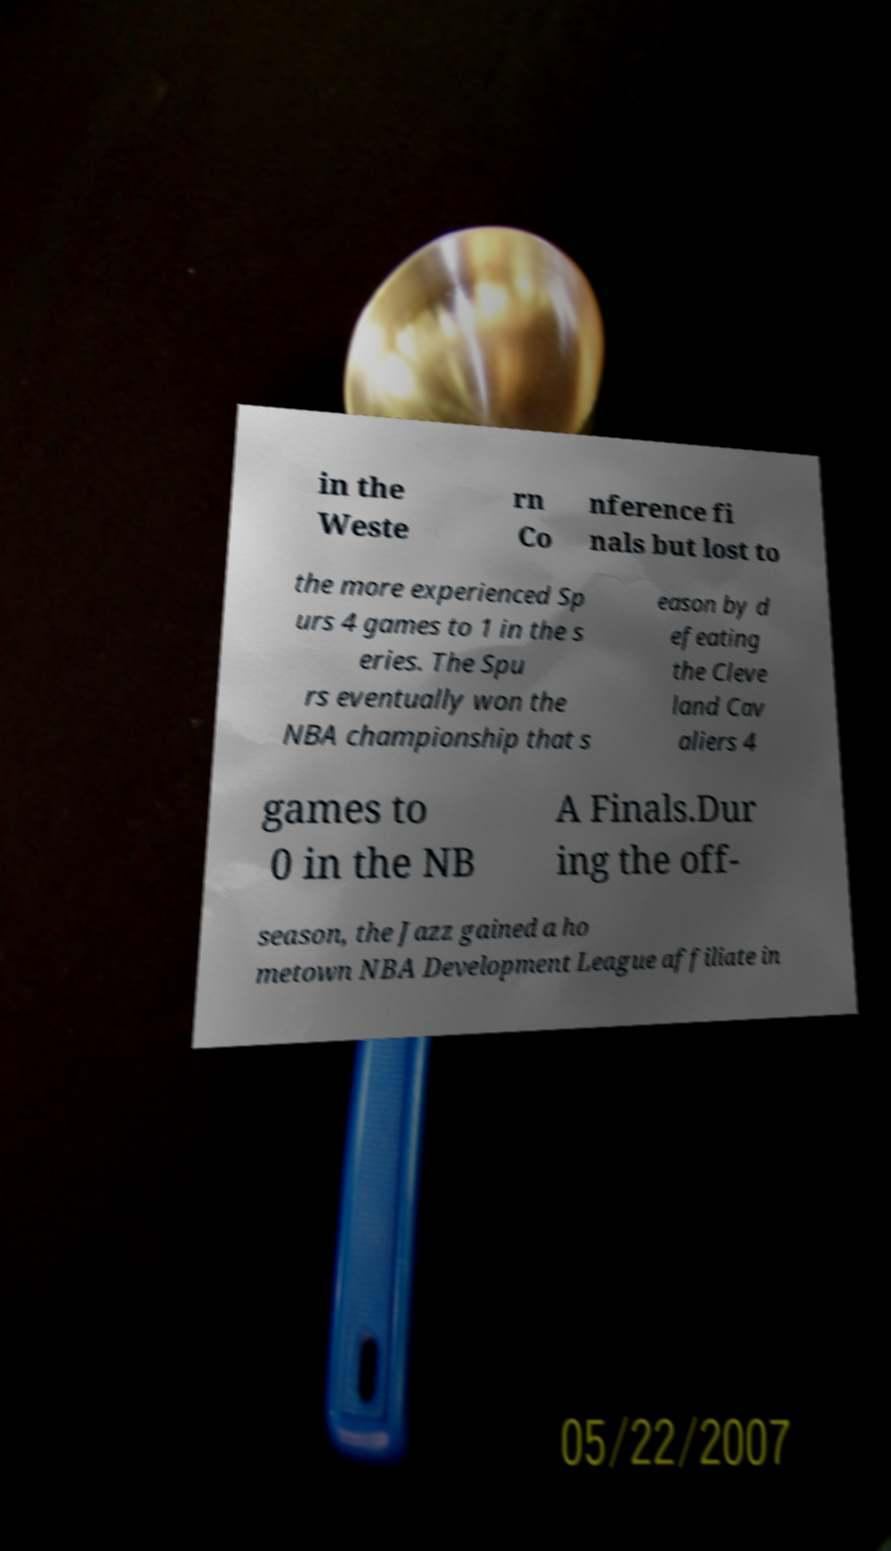Can you accurately transcribe the text from the provided image for me? in the Weste rn Co nference fi nals but lost to the more experienced Sp urs 4 games to 1 in the s eries. The Spu rs eventually won the NBA championship that s eason by d efeating the Cleve land Cav aliers 4 games to 0 in the NB A Finals.Dur ing the off- season, the Jazz gained a ho metown NBA Development League affiliate in 